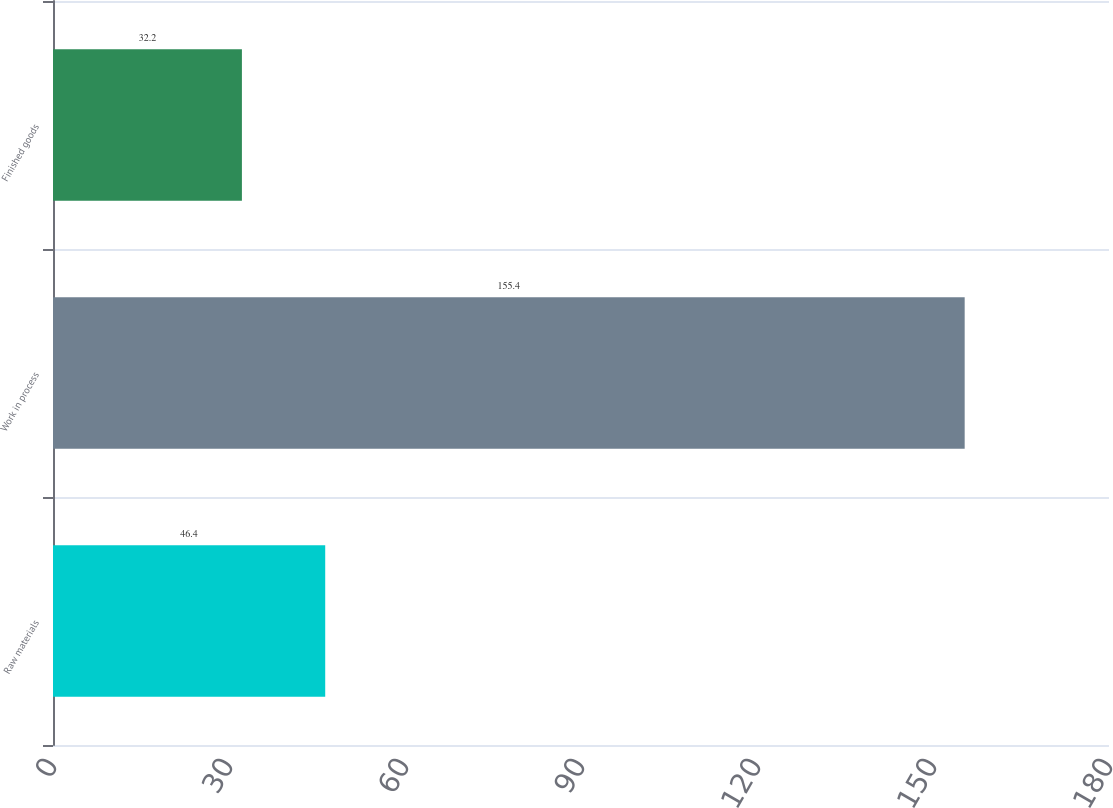<chart> <loc_0><loc_0><loc_500><loc_500><bar_chart><fcel>Raw materials<fcel>Work in process<fcel>Finished goods<nl><fcel>46.4<fcel>155.4<fcel>32.2<nl></chart> 